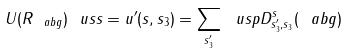<formula> <loc_0><loc_0><loc_500><loc_500>U ( R _ { \ a b g } ) \ u s s = u ^ { \prime } ( s , s _ { 3 } ) = \sum _ { s _ { 3 } ^ { \prime } } \ u s p D ^ { s } _ { s ^ { \prime } _ { 3 } , s _ { 3 } } ( \ a b g )</formula> 